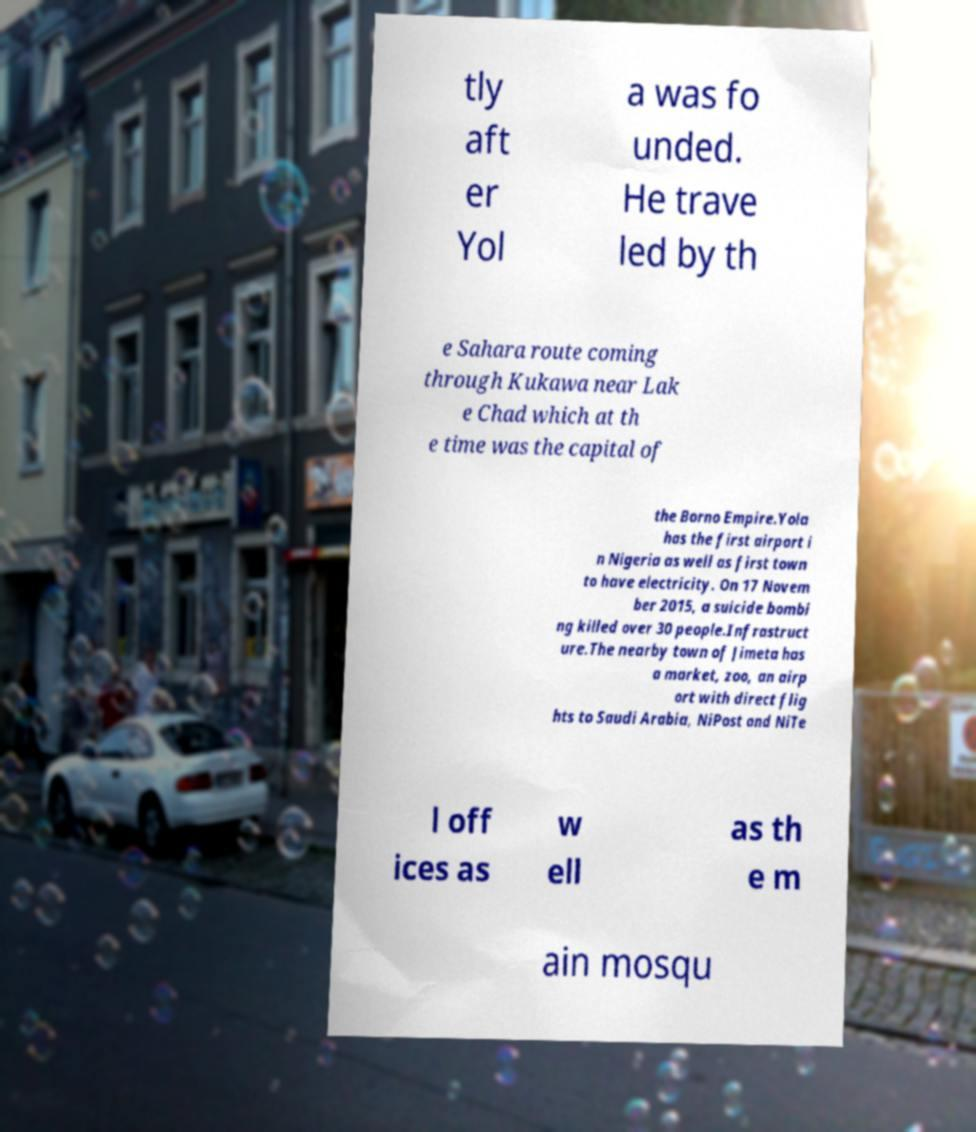Can you read and provide the text displayed in the image?This photo seems to have some interesting text. Can you extract and type it out for me? tly aft er Yol a was fo unded. He trave led by th e Sahara route coming through Kukawa near Lak e Chad which at th e time was the capital of the Borno Empire.Yola has the first airport i n Nigeria as well as first town to have electricity. On 17 Novem ber 2015, a suicide bombi ng killed over 30 people.Infrastruct ure.The nearby town of Jimeta has a market, zoo, an airp ort with direct flig hts to Saudi Arabia, NiPost and NiTe l off ices as w ell as th e m ain mosqu 